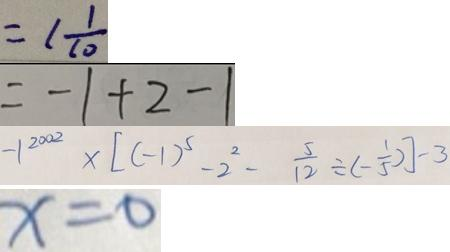<formula> <loc_0><loc_0><loc_500><loc_500>= 1 \frac { 1 } { 1 0 } 
 = - 1 + 2 - 1 
 - 1 ^ { 2 0 0 2 } \times [ ( - 1 ) ^ { 5 } - 2 ^ { 2 } - \frac { 5 } { 1 2 } \div ( - \frac { 1 } { 5 } ) ] - 3 
 x = 0</formula> 